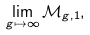Convert formula to latex. <formula><loc_0><loc_0><loc_500><loc_500>\lim _ { g \mapsto \infty } \mathcal { M } _ { g , 1 } ,</formula> 